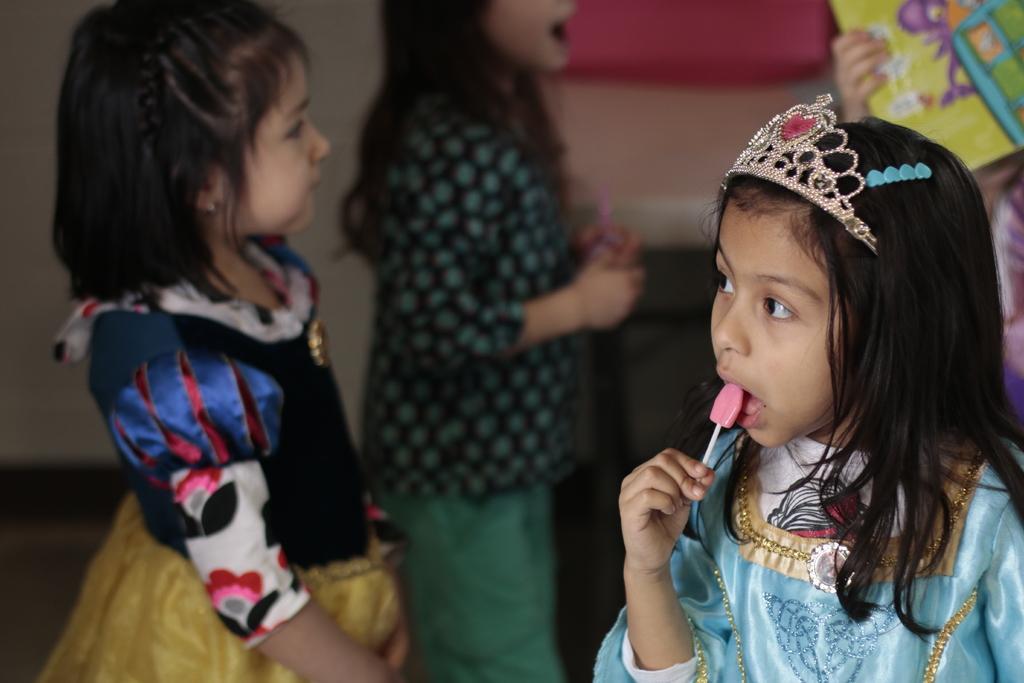Describe this image in one or two sentences. In this image I can see the group of people with different color dresses. I can see one person holding the food and another person holding an object. I can see the blurred background. 